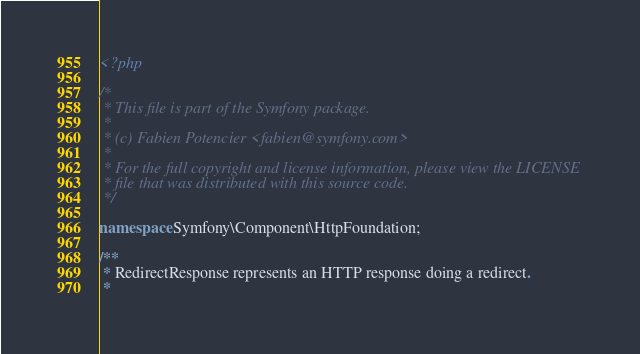<code> <loc_0><loc_0><loc_500><loc_500><_PHP_><?php

/*
 * This file is part of the Symfony package.
 *
 * (c) Fabien Potencier <fabien@symfony.com>
 *
 * For the full copyright and license information, please view the LICENSE
 * file that was distributed with this source code.
 */

namespace Symfony\Component\HttpFoundation;

/**
 * RedirectResponse represents an HTTP response doing a redirect.
 *</code> 